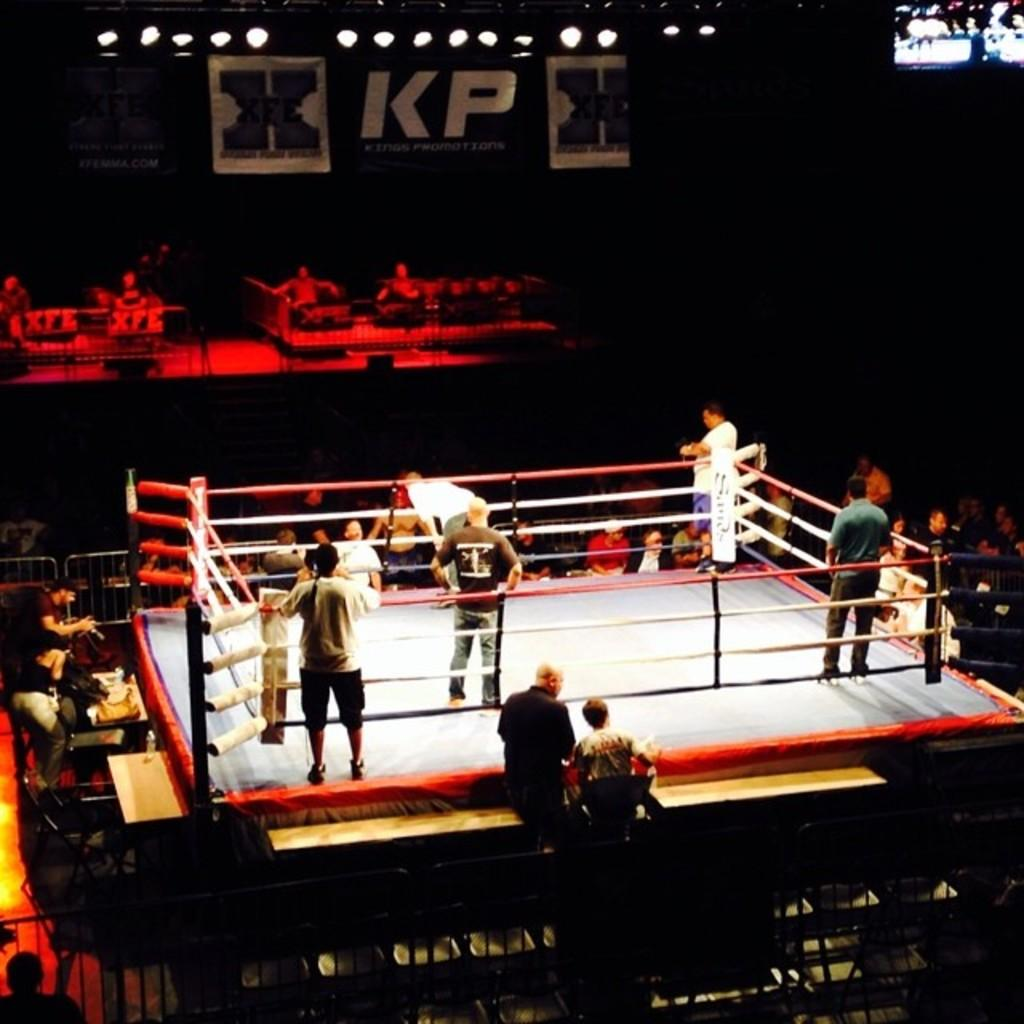<image>
Present a compact description of the photo's key features. boxing ring with people standing around and overhead banners with X, KP, and X 